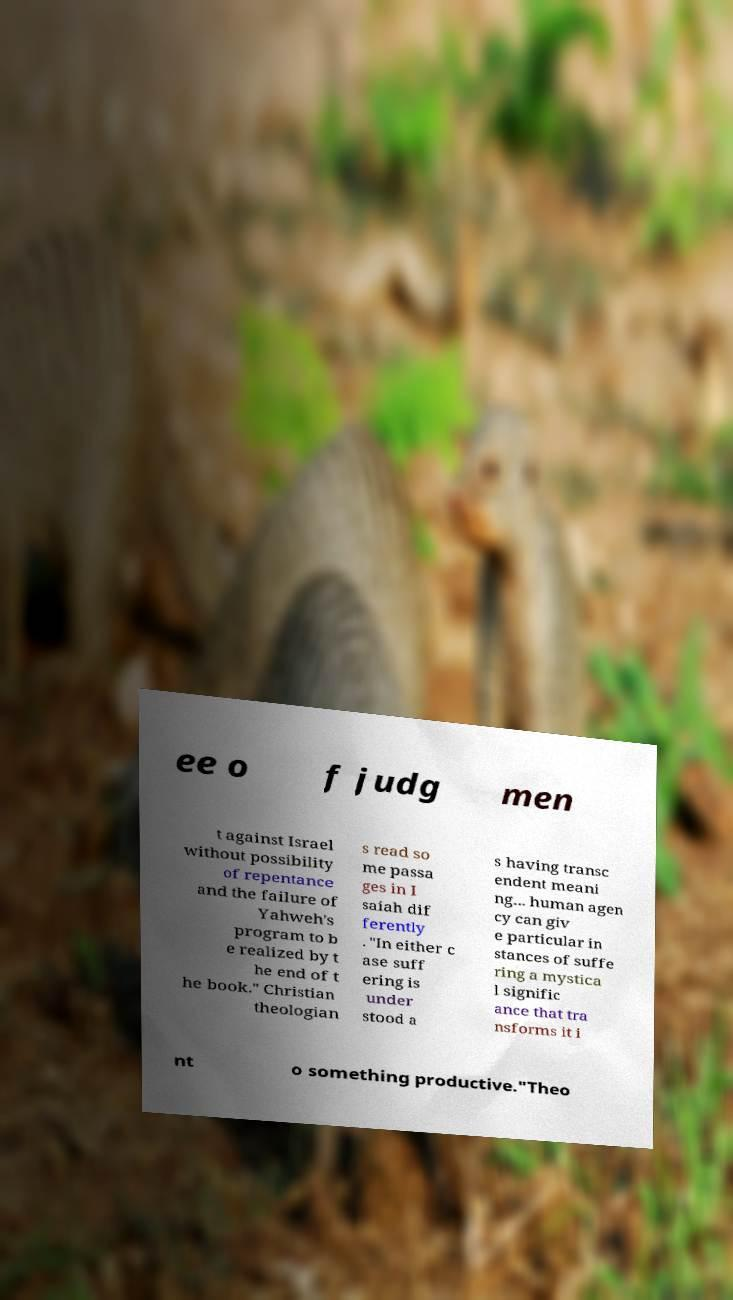For documentation purposes, I need the text within this image transcribed. Could you provide that? ee o f judg men t against Israel without possibility of repentance and the failure of Yahweh's program to b e realized by t he end of t he book." Christian theologian s read so me passa ges in I saiah dif ferently . "In either c ase suff ering is under stood a s having transc endent meani ng... human agen cy can giv e particular in stances of suffe ring a mystica l signific ance that tra nsforms it i nt o something productive."Theo 